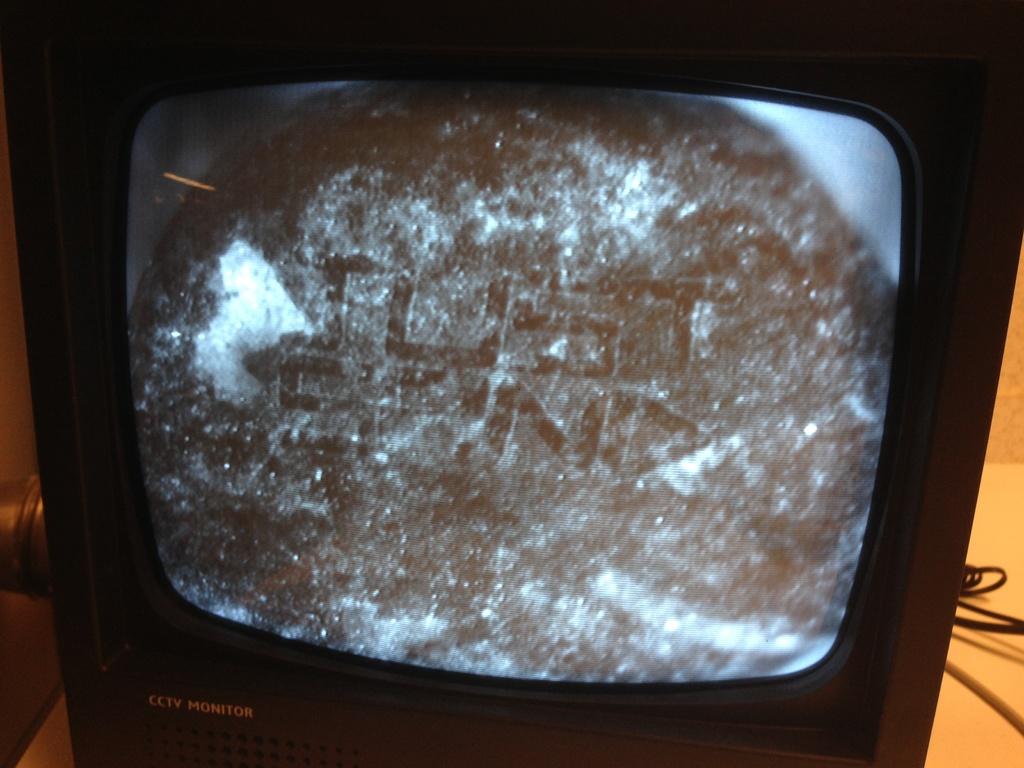What is this ?
Provide a short and direct response. Cctv monitor. What is printed on the bottom left of the tv?
Make the answer very short. Cctv monitor. 